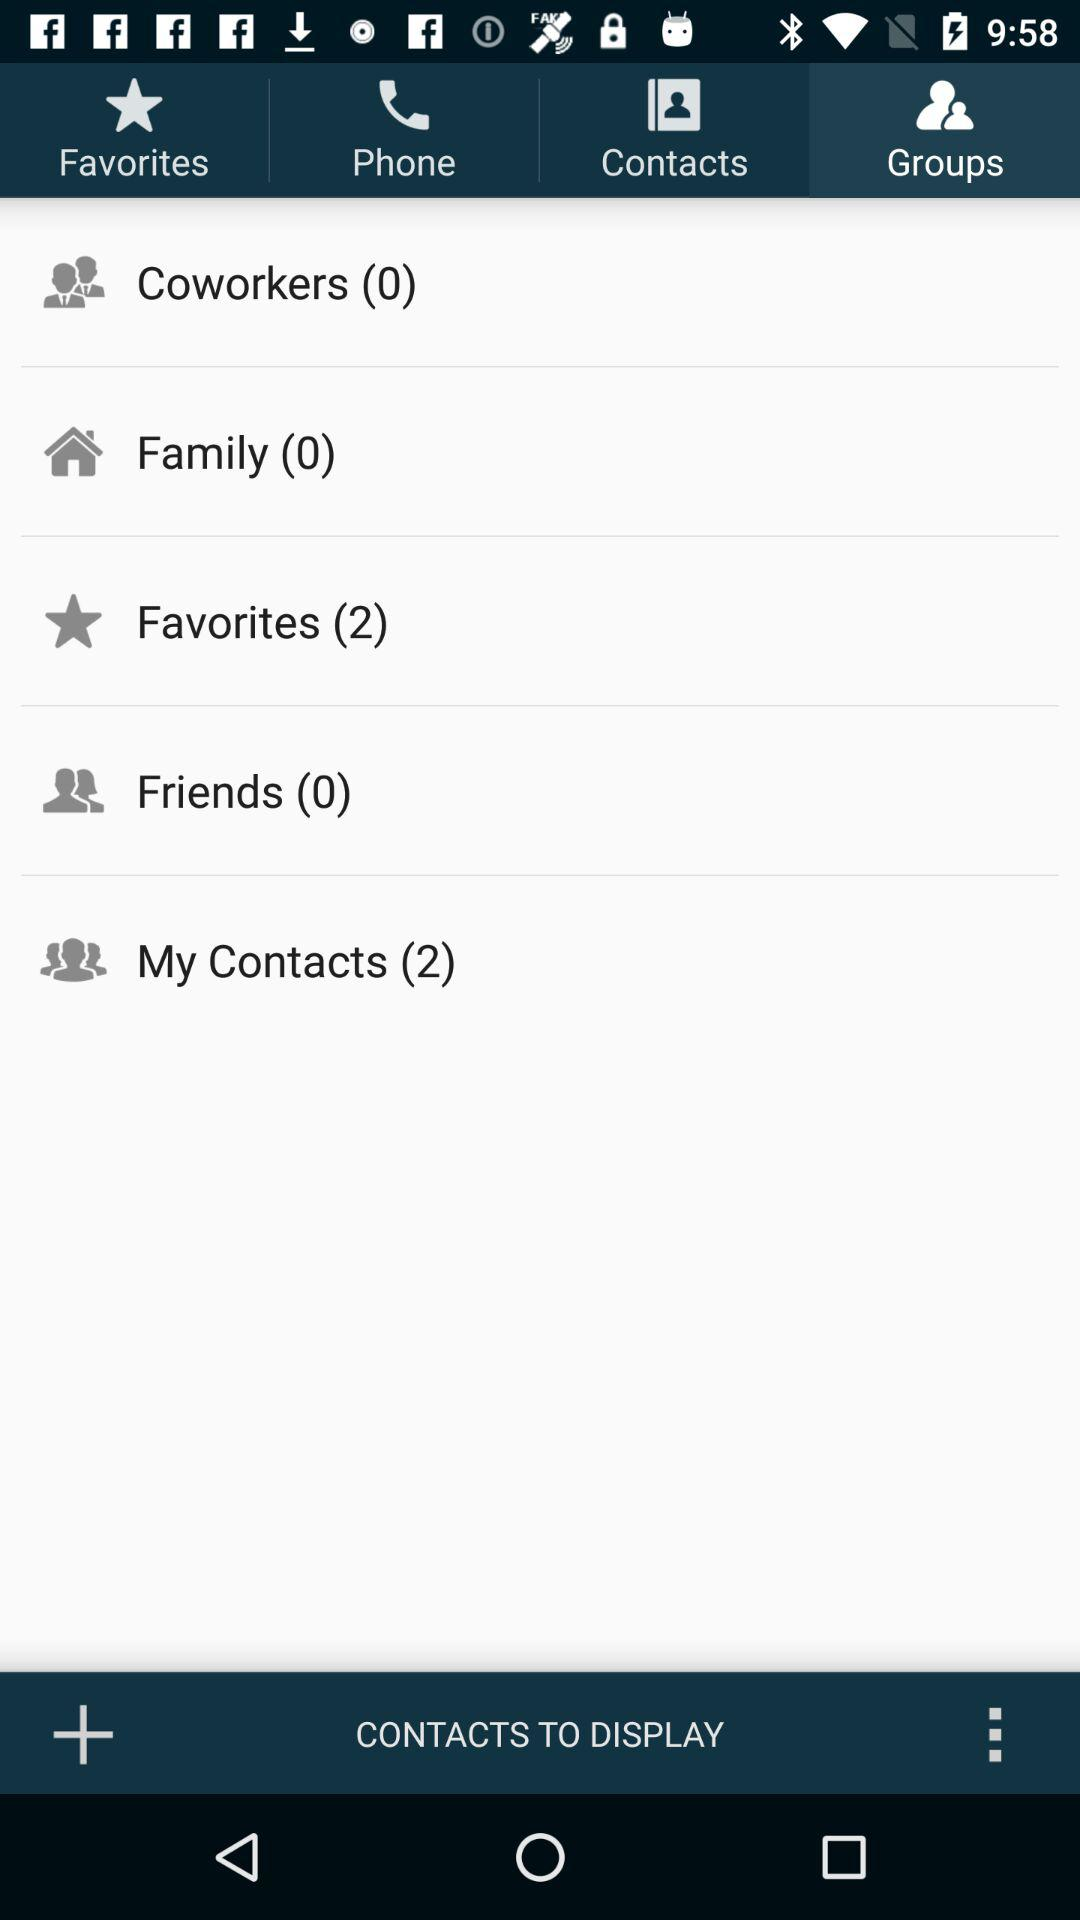What is the total number of added favorites? The total number of added favorites is 2. 